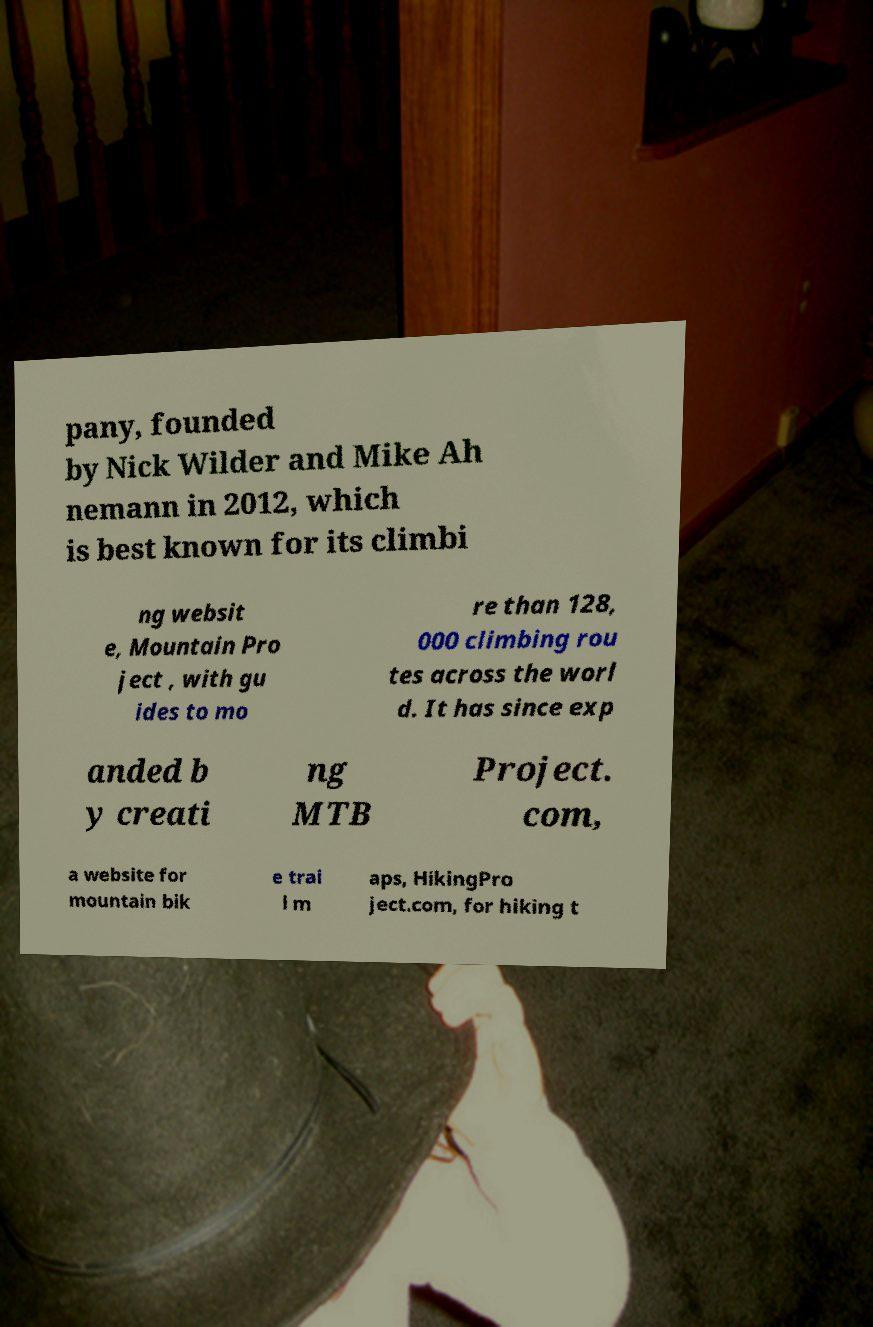Could you assist in decoding the text presented in this image and type it out clearly? pany, founded by Nick Wilder and Mike Ah nemann in 2012, which is best known for its climbi ng websit e, Mountain Pro ject , with gu ides to mo re than 128, 000 climbing rou tes across the worl d. It has since exp anded b y creati ng MTB Project. com, a website for mountain bik e trai l m aps, HikingPro ject.com, for hiking t 